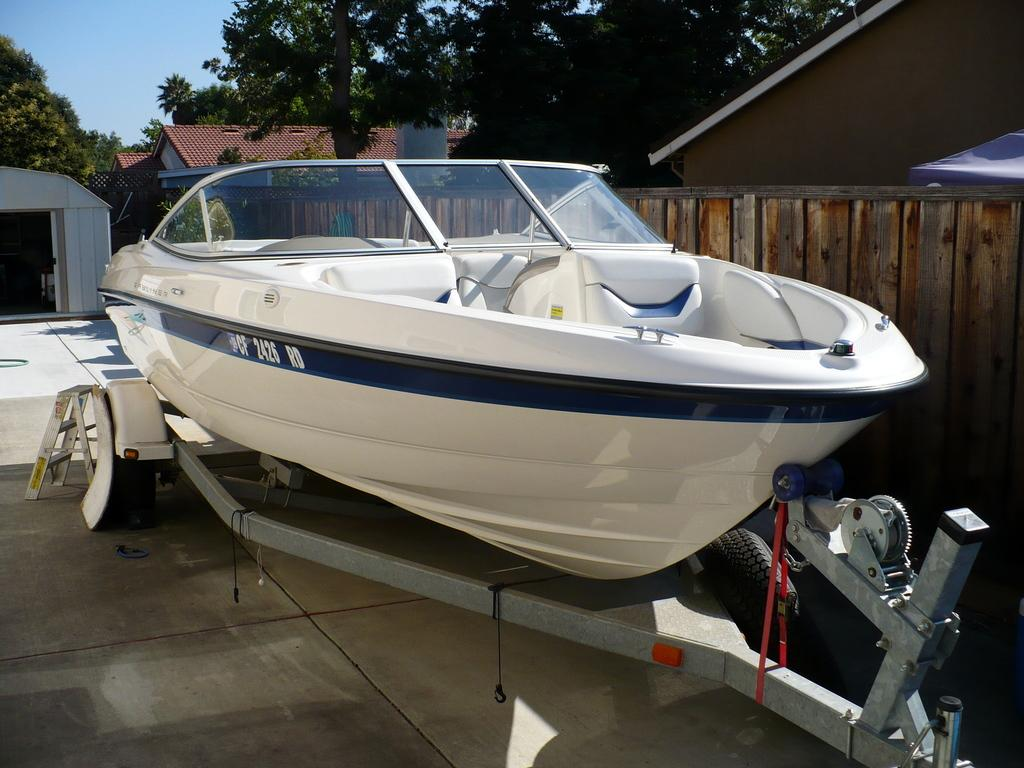What is the main subject of the image? There is a boat in the image. What can be seen in the background of the image? There are houses and trees in the background of the image. What type of fencing is present in the image? There is a wooden fencing in the image. What is visible at the bottom of the image? There is a floor visible at the bottom of the image. How many clocks are visible in the image? There are no clocks present in the image. What type of industry is depicted in the image? There is no industry depicted in the image; it features a boat, houses, trees, wooden fencing, and a floor. 